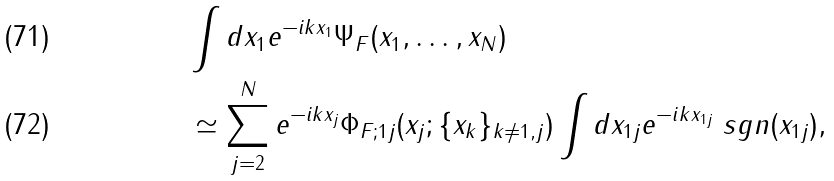<formula> <loc_0><loc_0><loc_500><loc_500>& \int d x _ { 1 } e ^ { - i k x _ { 1 } } \Psi _ { F } ( x _ { 1 } , \dots , x _ { N } ) \\ & \simeq \sum _ { j = 2 } ^ { N } e ^ { - i k x _ { j } } \Phi _ { F ; 1 j } ( x _ { j } ; \{ x _ { k } \} _ { k \neq 1 , j } ) \int d x _ { 1 j } e ^ { - i k x _ { 1 j } } \ s g n ( x _ { 1 j } ) ,</formula> 